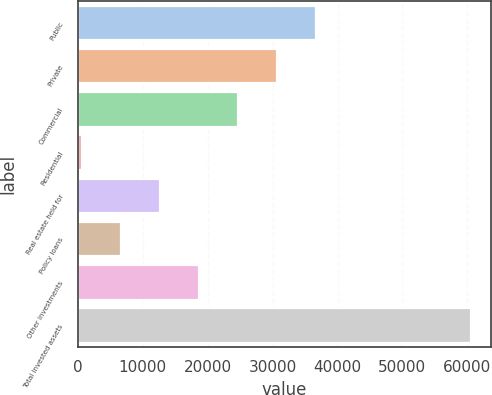Convert chart to OTSL. <chart><loc_0><loc_0><loc_500><loc_500><bar_chart><fcel>Public<fcel>Private<fcel>Commercial<fcel>Residential<fcel>Real estate held for<fcel>Policy loans<fcel>Other investments<fcel>Total invested assets<nl><fcel>36613.8<fcel>30605.7<fcel>24597.6<fcel>565.4<fcel>12581.5<fcel>6573.46<fcel>18589.6<fcel>60646<nl></chart> 